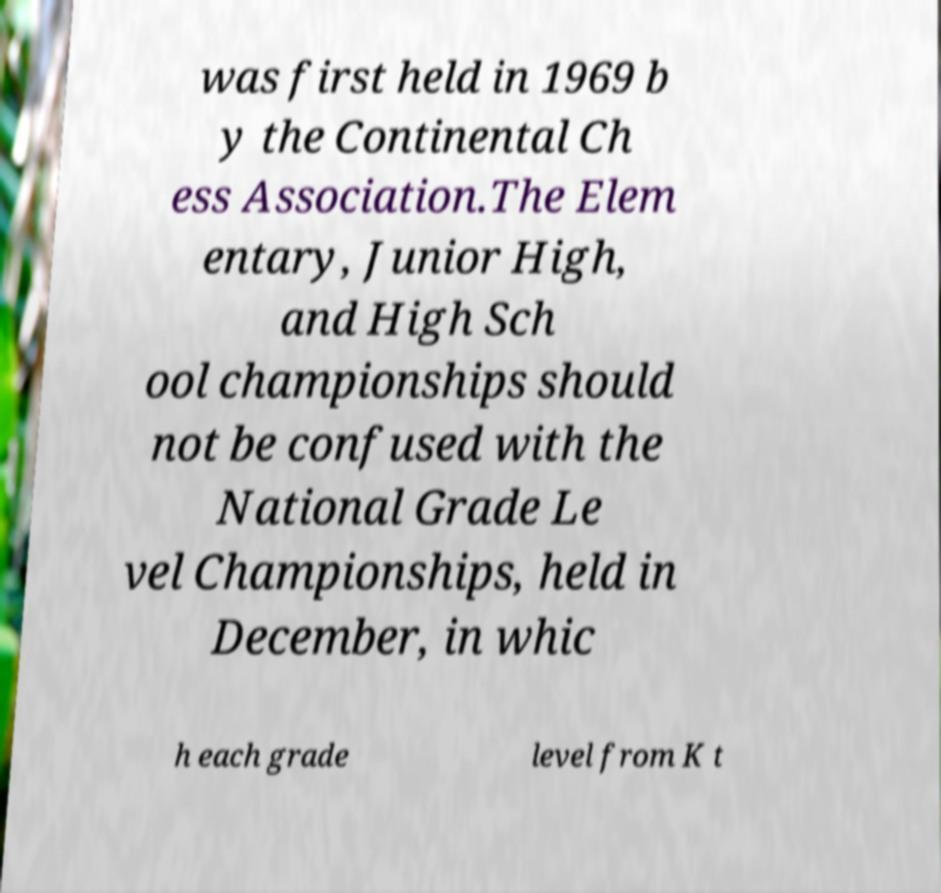Can you read and provide the text displayed in the image?This photo seems to have some interesting text. Can you extract and type it out for me? was first held in 1969 b y the Continental Ch ess Association.The Elem entary, Junior High, and High Sch ool championships should not be confused with the National Grade Le vel Championships, held in December, in whic h each grade level from K t 